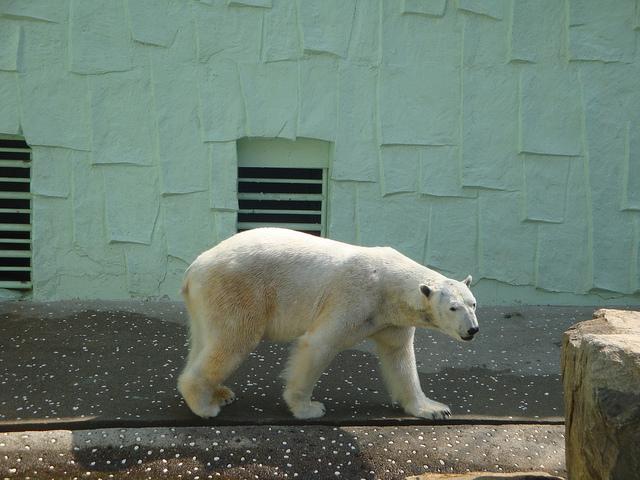How many polar bears are there?
Short answer required. 1. Is the bear dry?
Keep it brief. Yes. Is this the animal's natural habitat?
Be succinct. No. What color is the bear?
Be succinct. White. 